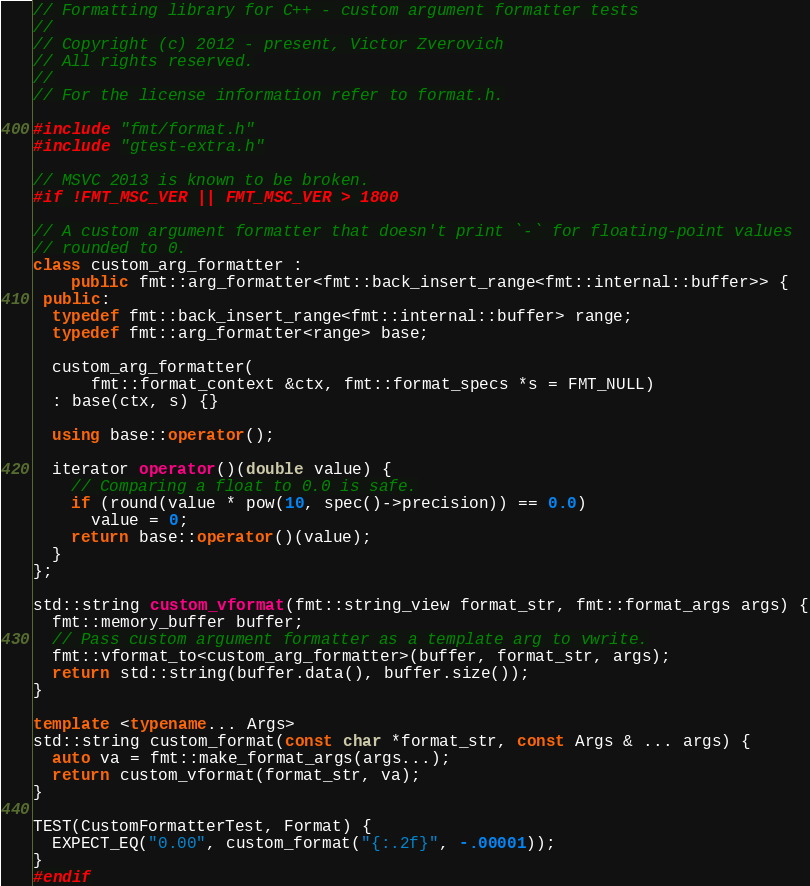<code> <loc_0><loc_0><loc_500><loc_500><_C++_>// Formatting library for C++ - custom argument formatter tests
//
// Copyright (c) 2012 - present, Victor Zverovich
// All rights reserved.
//
// For the license information refer to format.h.

#include "fmt/format.h"
#include "gtest-extra.h"

// MSVC 2013 is known to be broken.
#if !FMT_MSC_VER || FMT_MSC_VER > 1800

// A custom argument formatter that doesn't print `-` for floating-point values
// rounded to 0.
class custom_arg_formatter :
    public fmt::arg_formatter<fmt::back_insert_range<fmt::internal::buffer>> {
 public:
  typedef fmt::back_insert_range<fmt::internal::buffer> range;
  typedef fmt::arg_formatter<range> base;

  custom_arg_formatter(
      fmt::format_context &ctx, fmt::format_specs *s = FMT_NULL)
  : base(ctx, s) {}

  using base::operator();

  iterator operator()(double value) {
    // Comparing a float to 0.0 is safe.
    if (round(value * pow(10, spec()->precision)) == 0.0)
      value = 0;
    return base::operator()(value);
  }
};

std::string custom_vformat(fmt::string_view format_str, fmt::format_args args) {
  fmt::memory_buffer buffer;
  // Pass custom argument formatter as a template arg to vwrite.
  fmt::vformat_to<custom_arg_formatter>(buffer, format_str, args);
  return std::string(buffer.data(), buffer.size());
}

template <typename... Args>
std::string custom_format(const char *format_str, const Args & ... args) {
  auto va = fmt::make_format_args(args...);
  return custom_vformat(format_str, va);
}

TEST(CustomFormatterTest, Format) {
  EXPECT_EQ("0.00", custom_format("{:.2f}", -.00001));
}
#endif
</code> 